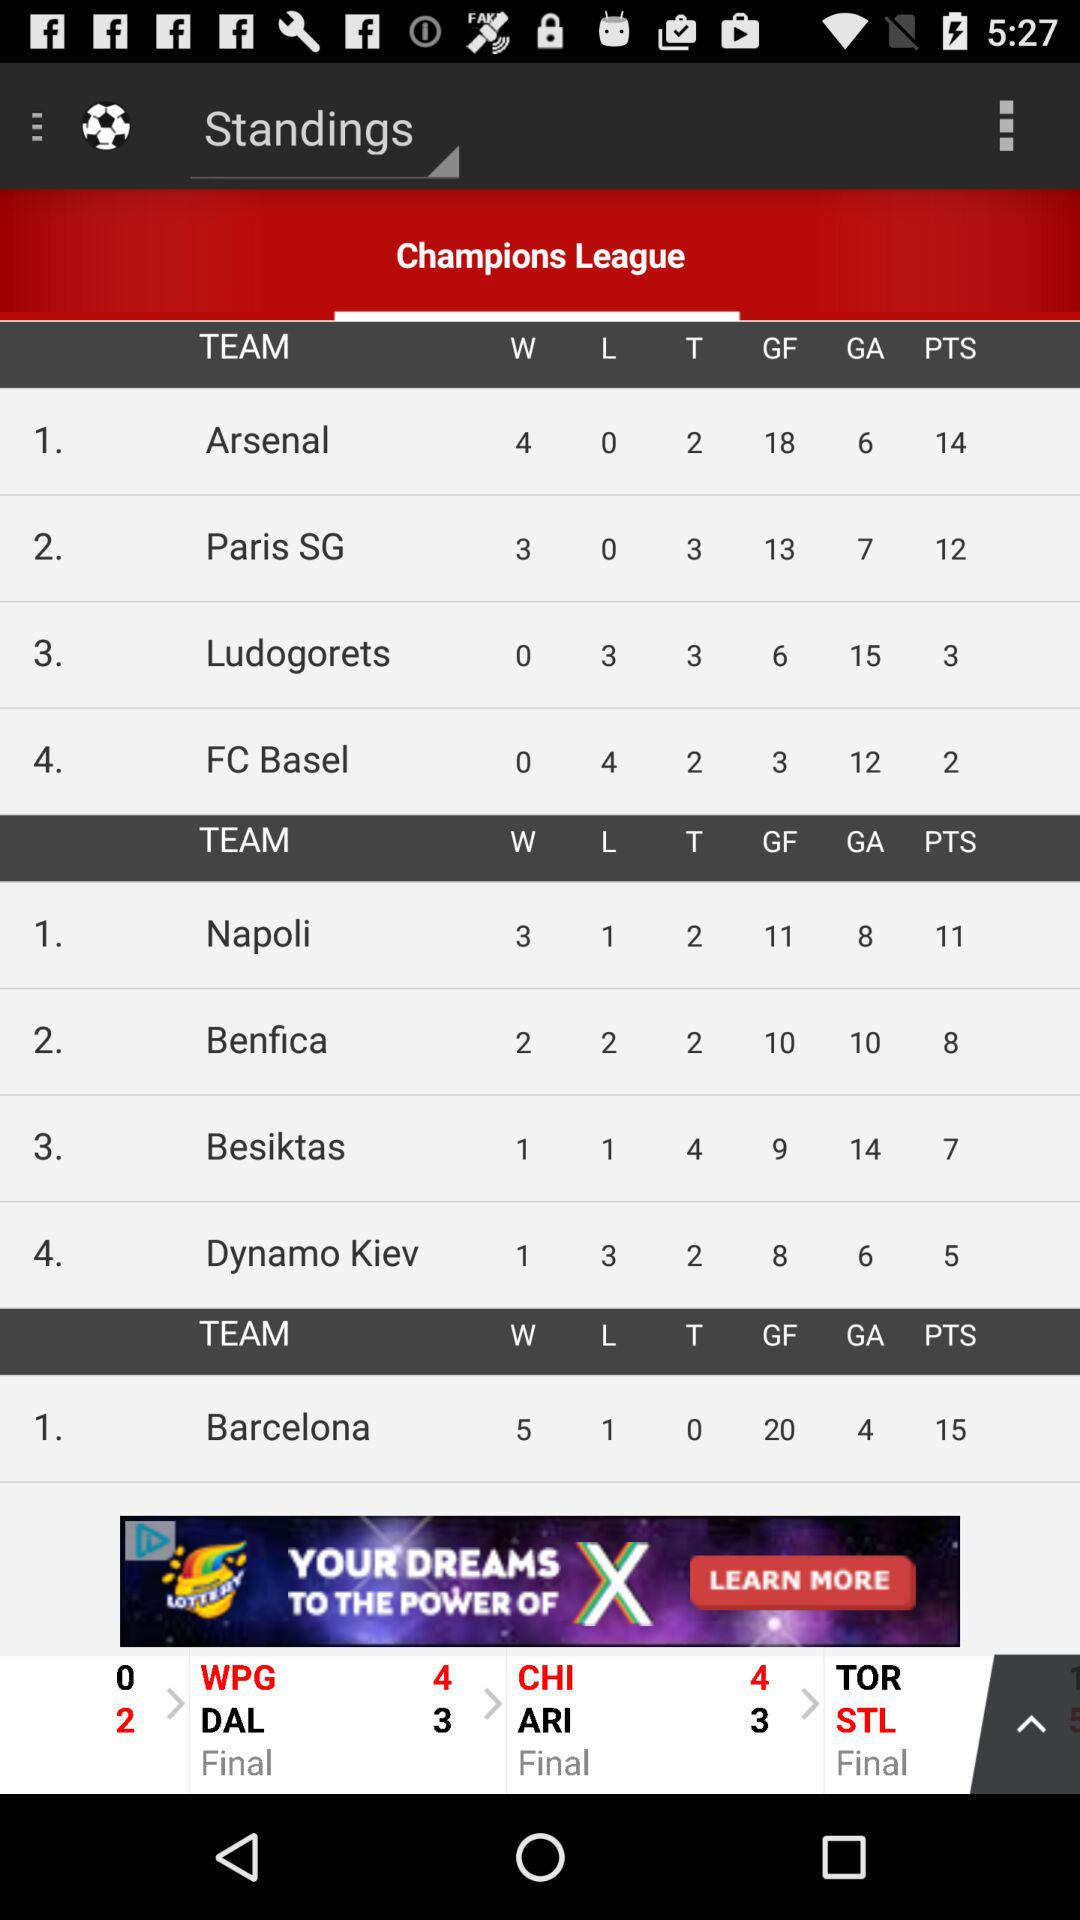Which team has the highest goal difference?
Answer the question using a single word or phrase. Barcelona 